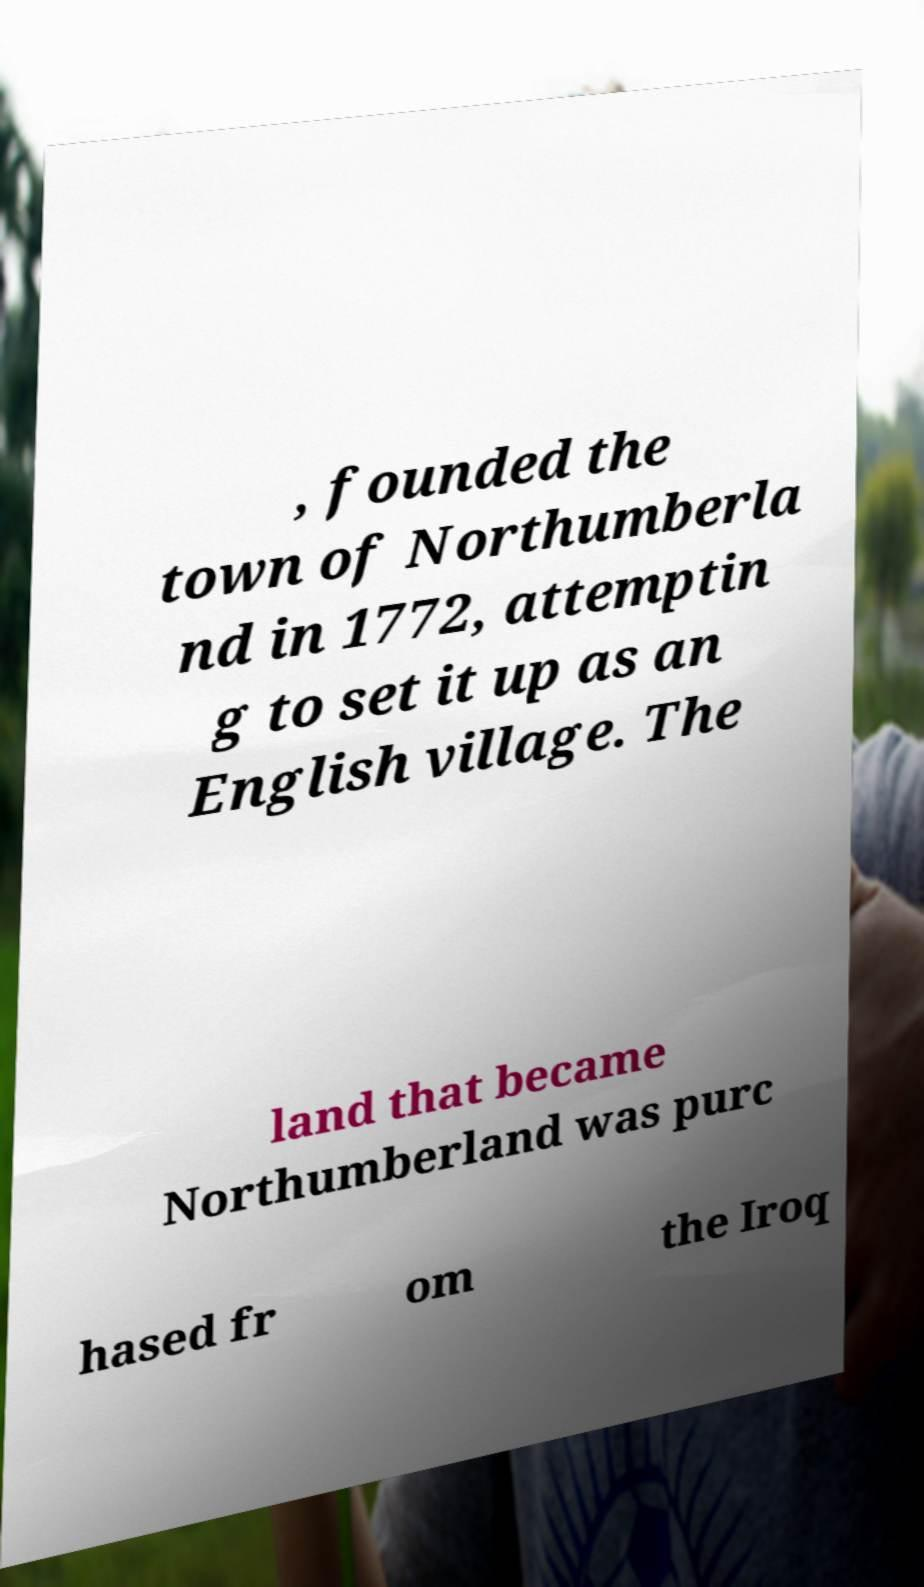Please read and relay the text visible in this image. What does it say? , founded the town of Northumberla nd in 1772, attemptin g to set it up as an English village. The land that became Northumberland was purc hased fr om the Iroq 